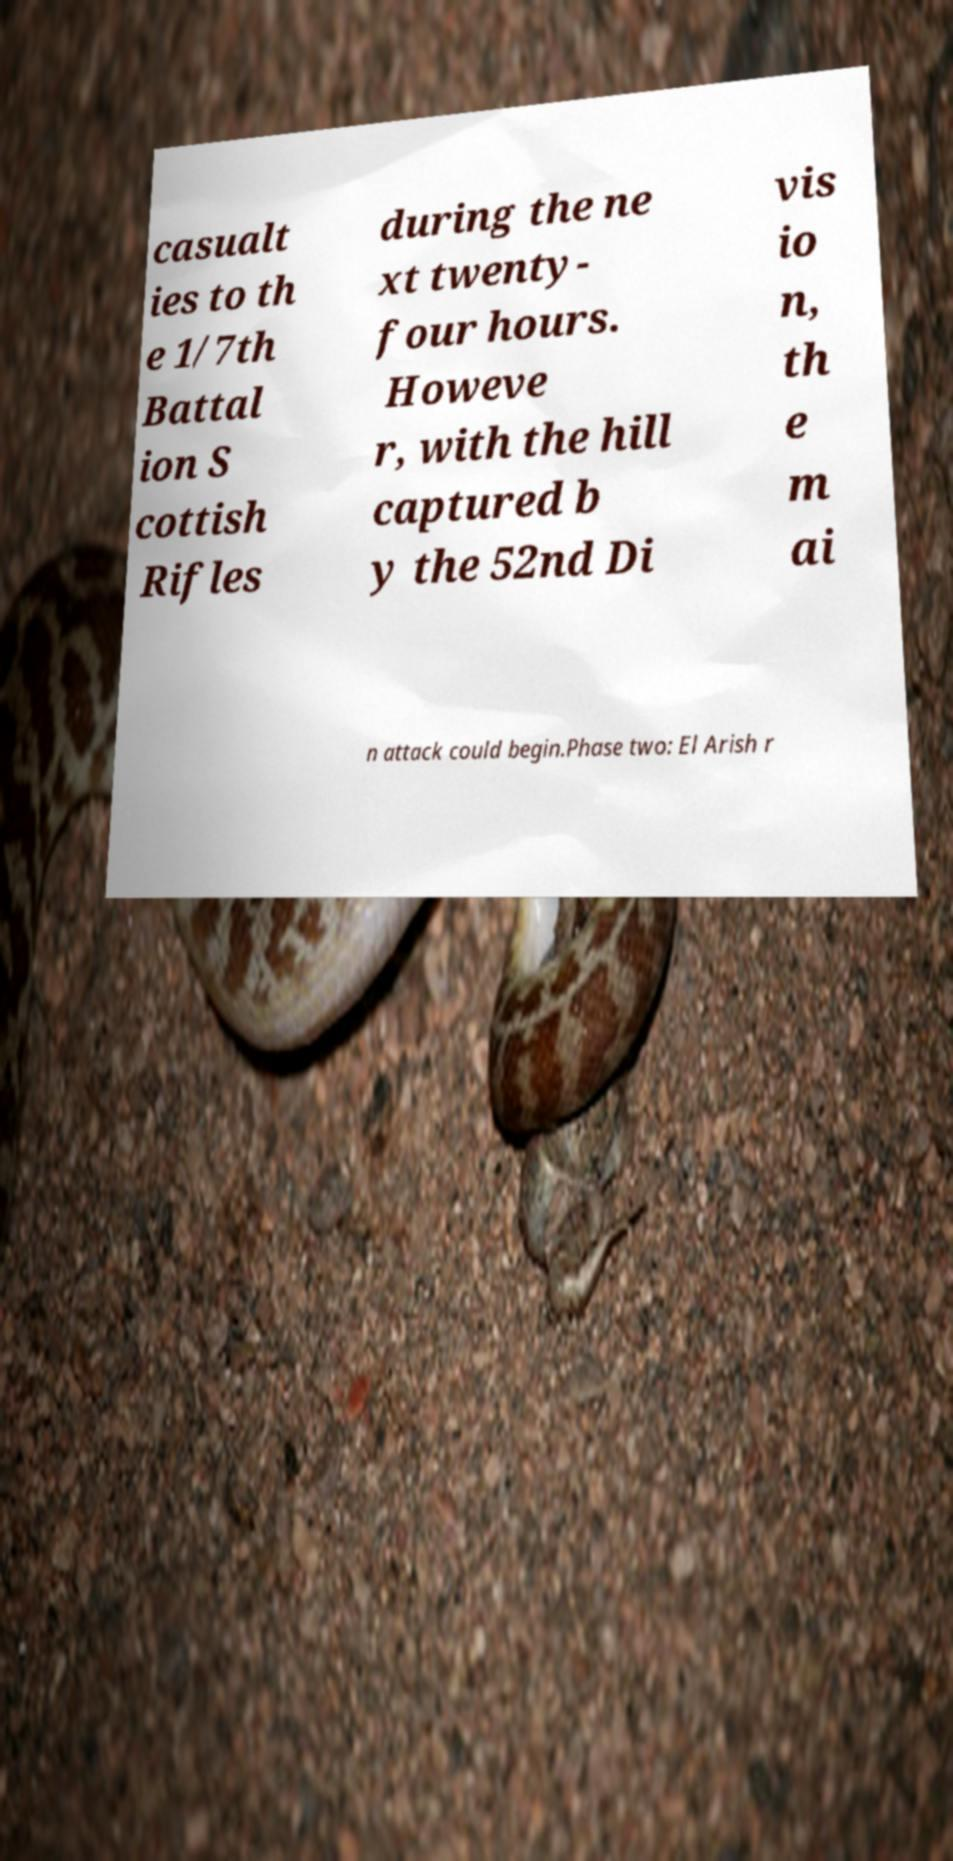Can you accurately transcribe the text from the provided image for me? casualt ies to th e 1/7th Battal ion S cottish Rifles during the ne xt twenty- four hours. Howeve r, with the hill captured b y the 52nd Di vis io n, th e m ai n attack could begin.Phase two: El Arish r 